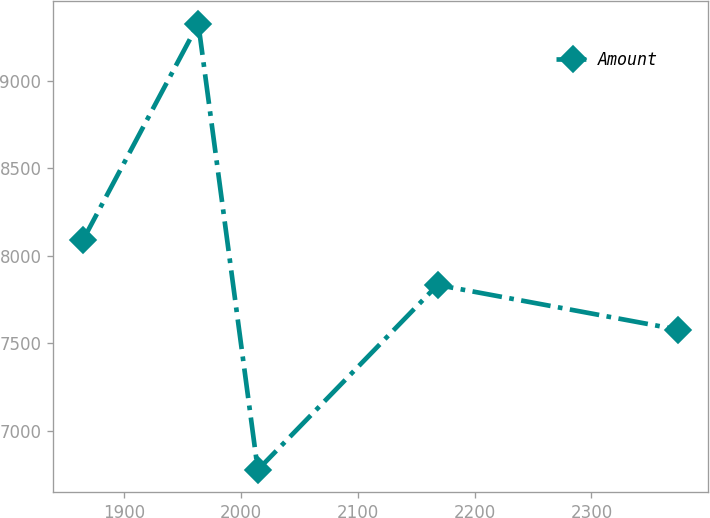Convert chart. <chart><loc_0><loc_0><loc_500><loc_500><line_chart><ecel><fcel>Amount<nl><fcel>1864.59<fcel>8087.75<nl><fcel>1963.42<fcel>9326.12<nl><fcel>2014.37<fcel>6776.35<nl><fcel>2168.26<fcel>7832.77<nl><fcel>2374.12<fcel>7577.79<nl></chart> 